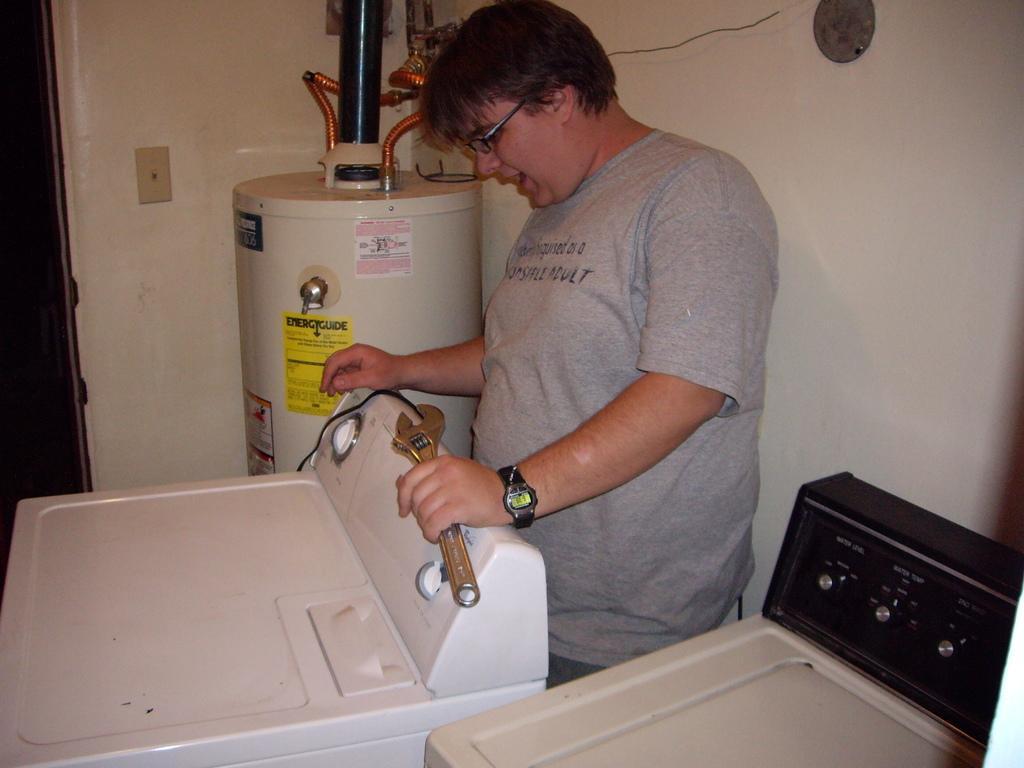Please provide a concise description of this image. This is an inside view. At the bottom there are few machine tools and there is a person wearing a t-shirt, standing and holding a tool in the hand. In the background there is an object placed at one corner of the room. In the background, I can see the wall. 